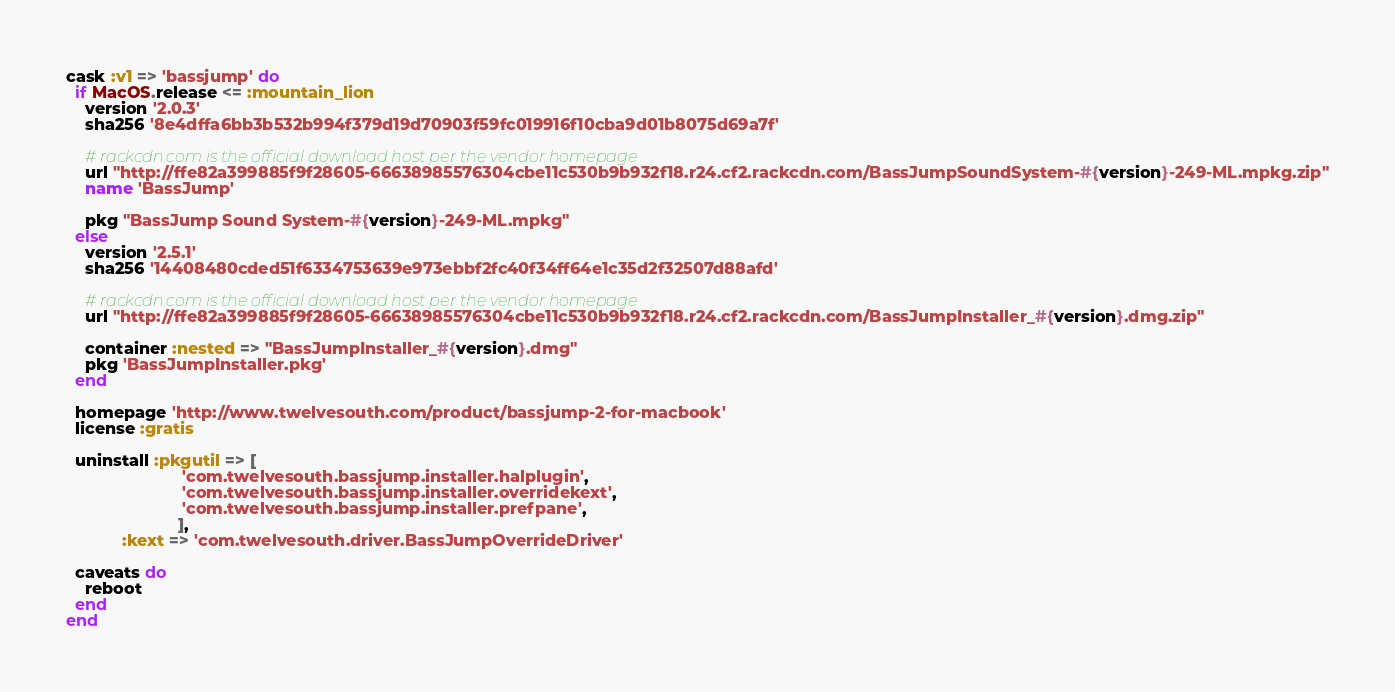<code> <loc_0><loc_0><loc_500><loc_500><_Ruby_>cask :v1 => 'bassjump' do
  if MacOS.release <= :mountain_lion
    version '2.0.3'
    sha256 '8e4dffa6bb3b532b994f379d19d70903f59fc019916f10cba9d01b8075d69a7f'

    # rackcdn.com is the official download host per the vendor homepage
    url "http://ffe82a399885f9f28605-66638985576304cbe11c530b9b932f18.r24.cf2.rackcdn.com/BassJumpSoundSystem-#{version}-249-ML.mpkg.zip"
    name 'BassJump'

    pkg "BassJump Sound System-#{version}-249-ML.mpkg"
  else
    version '2.5.1'
    sha256 '14408480cded51f6334753639e973ebbf2fc40f34ff64e1c35d2f32507d88afd'

    # rackcdn.com is the official download host per the vendor homepage
    url "http://ffe82a399885f9f28605-66638985576304cbe11c530b9b932f18.r24.cf2.rackcdn.com/BassJumpInstaller_#{version}.dmg.zip"

    container :nested => "BassJumpInstaller_#{version}.dmg"
    pkg 'BassJumpInstaller.pkg'
  end

  homepage 'http://www.twelvesouth.com/product/bassjump-2-for-macbook'
  license :gratis

  uninstall :pkgutil => [
                         'com.twelvesouth.bassjump.installer.halplugin',
                         'com.twelvesouth.bassjump.installer.overridekext',
                         'com.twelvesouth.bassjump.installer.prefpane',
                        ],
            :kext => 'com.twelvesouth.driver.BassJumpOverrideDriver'

  caveats do
    reboot
  end
end
</code> 